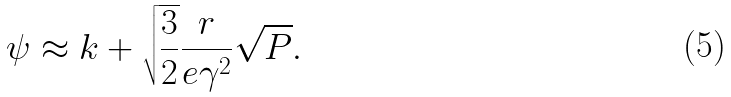<formula> <loc_0><loc_0><loc_500><loc_500>\psi \approx k + \sqrt { \frac { 3 } { 2 } } \frac { r } { e \gamma ^ { 2 } } \sqrt { P } .</formula> 